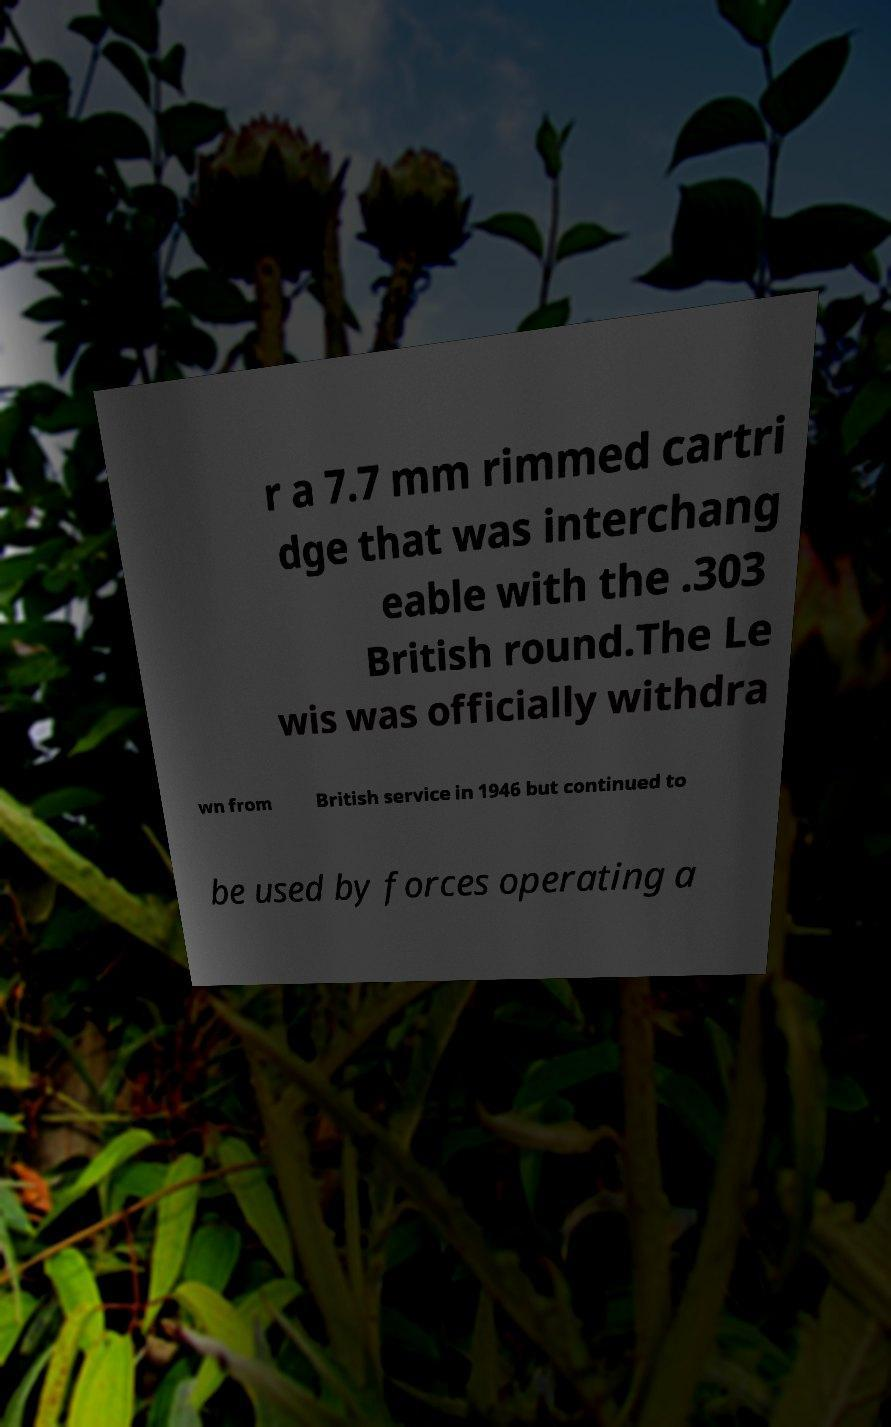What messages or text are displayed in this image? I need them in a readable, typed format. r a 7.7 mm rimmed cartri dge that was interchang eable with the .303 British round.The Le wis was officially withdra wn from British service in 1946 but continued to be used by forces operating a 